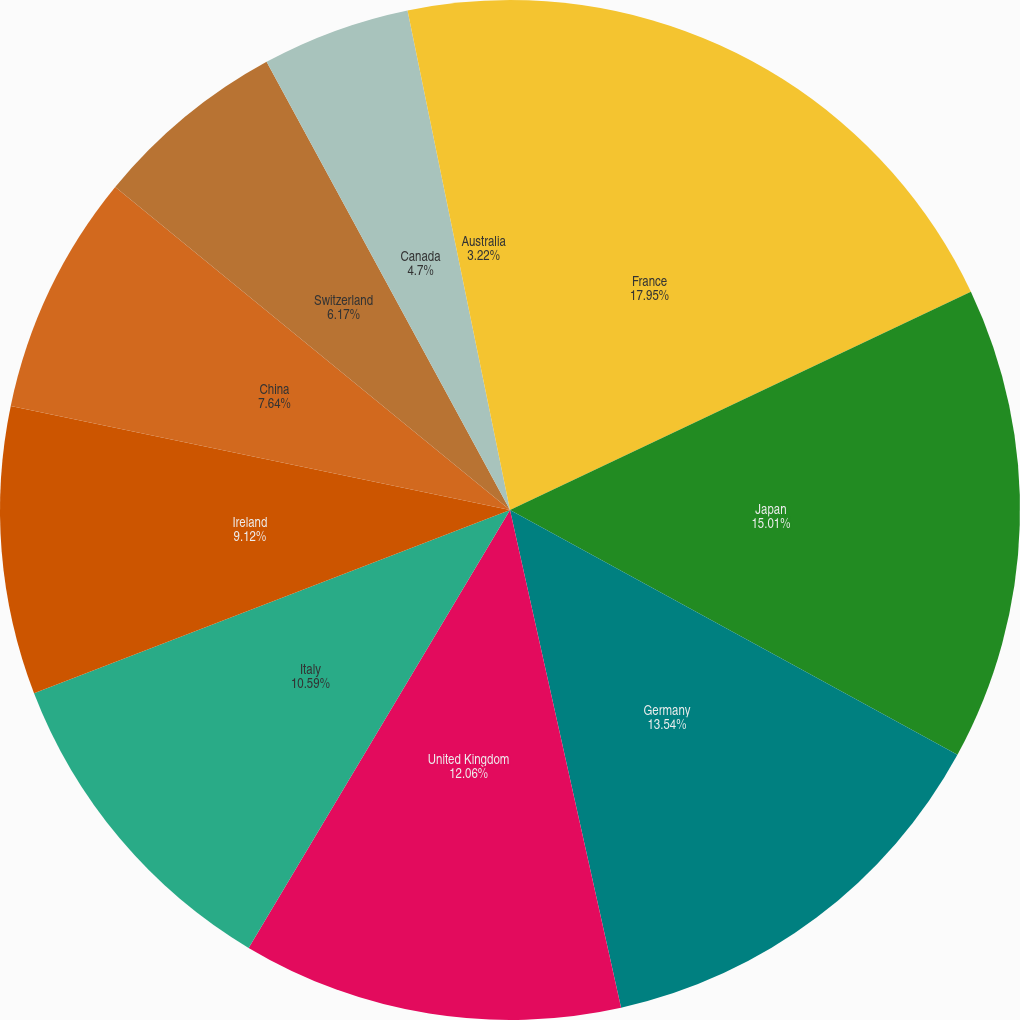<chart> <loc_0><loc_0><loc_500><loc_500><pie_chart><fcel>France<fcel>Japan<fcel>Germany<fcel>United Kingdom<fcel>Italy<fcel>Ireland<fcel>China<fcel>Switzerland<fcel>Canada<fcel>Australia<nl><fcel>17.96%<fcel>15.01%<fcel>13.54%<fcel>12.06%<fcel>10.59%<fcel>9.12%<fcel>7.64%<fcel>6.17%<fcel>4.7%<fcel>3.22%<nl></chart> 